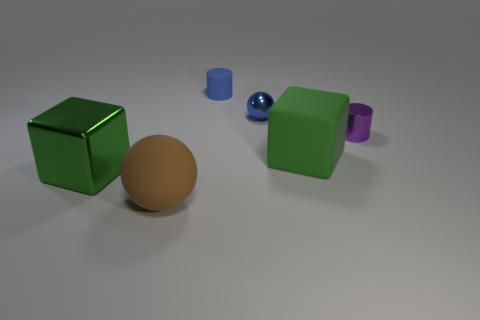Add 4 big matte things. How many objects exist? 10 Subtract all cylinders. How many objects are left? 4 Subtract all small blue matte cylinders. Subtract all small brown metallic cylinders. How many objects are left? 5 Add 2 shiny spheres. How many shiny spheres are left? 3 Add 6 tiny blue cylinders. How many tiny blue cylinders exist? 7 Subtract 1 blue spheres. How many objects are left? 5 